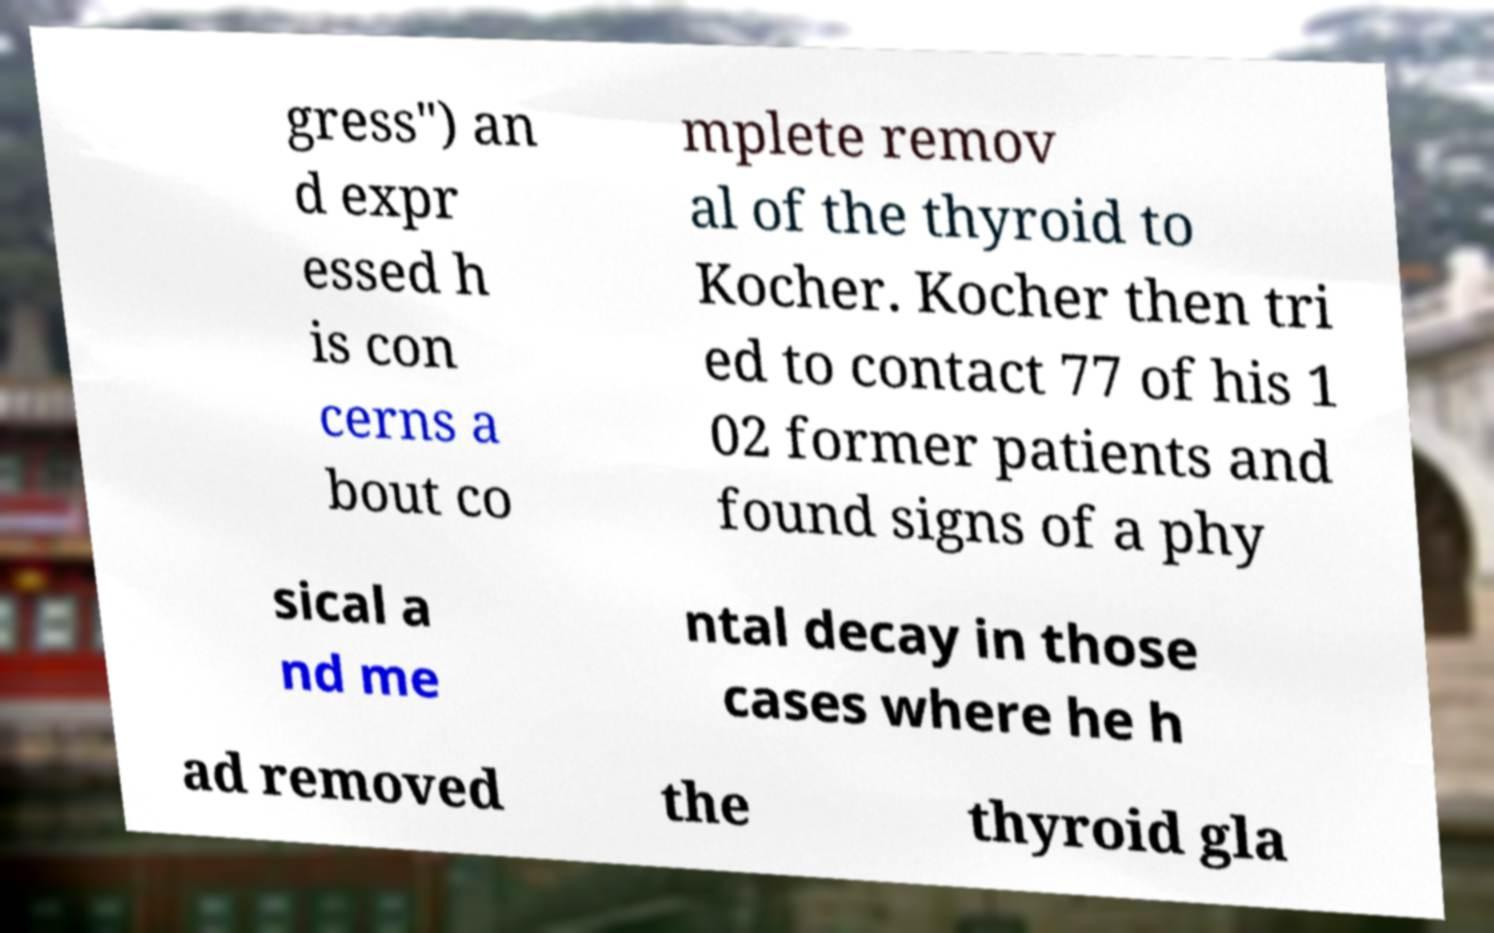Can you accurately transcribe the text from the provided image for me? gress") an d expr essed h is con cerns a bout co mplete remov al of the thyroid to Kocher. Kocher then tri ed to contact 77 of his 1 02 former patients and found signs of a phy sical a nd me ntal decay in those cases where he h ad removed the thyroid gla 